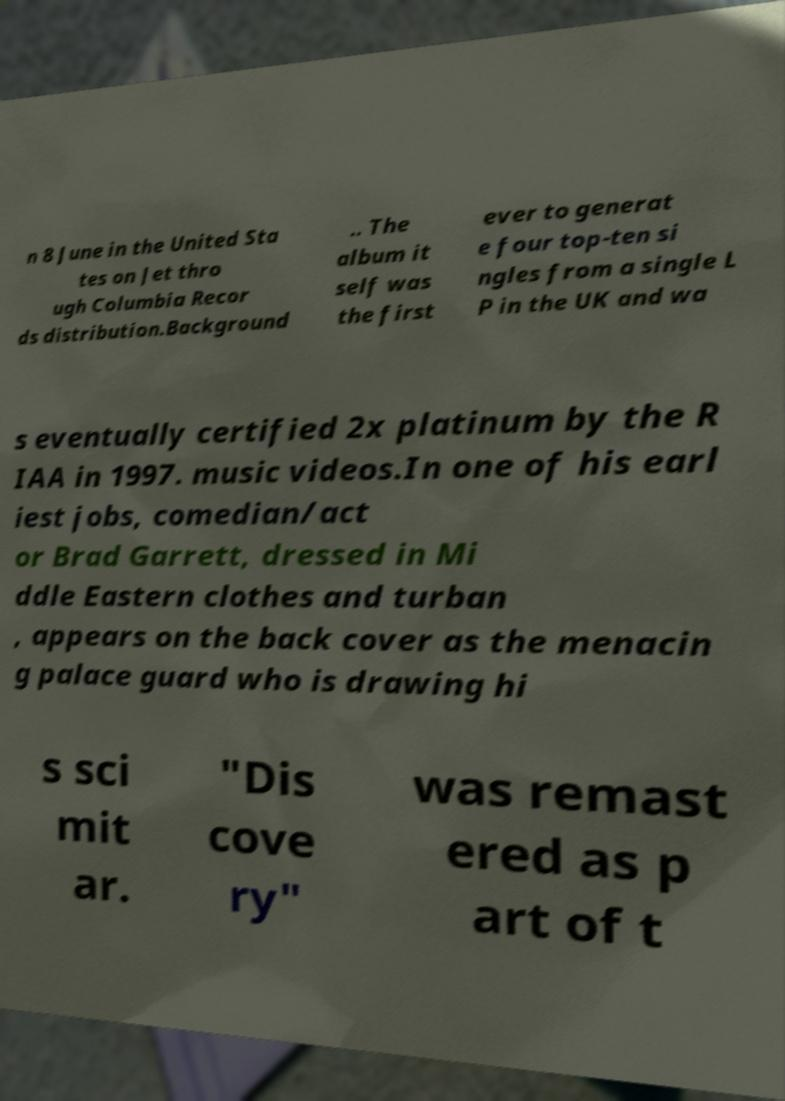For documentation purposes, I need the text within this image transcribed. Could you provide that? n 8 June in the United Sta tes on Jet thro ugh Columbia Recor ds distribution.Background .. The album it self was the first ever to generat e four top-ten si ngles from a single L P in the UK and wa s eventually certified 2x platinum by the R IAA in 1997. music videos.In one of his earl iest jobs, comedian/act or Brad Garrett, dressed in Mi ddle Eastern clothes and turban , appears on the back cover as the menacin g palace guard who is drawing hi s sci mit ar. "Dis cove ry" was remast ered as p art of t 